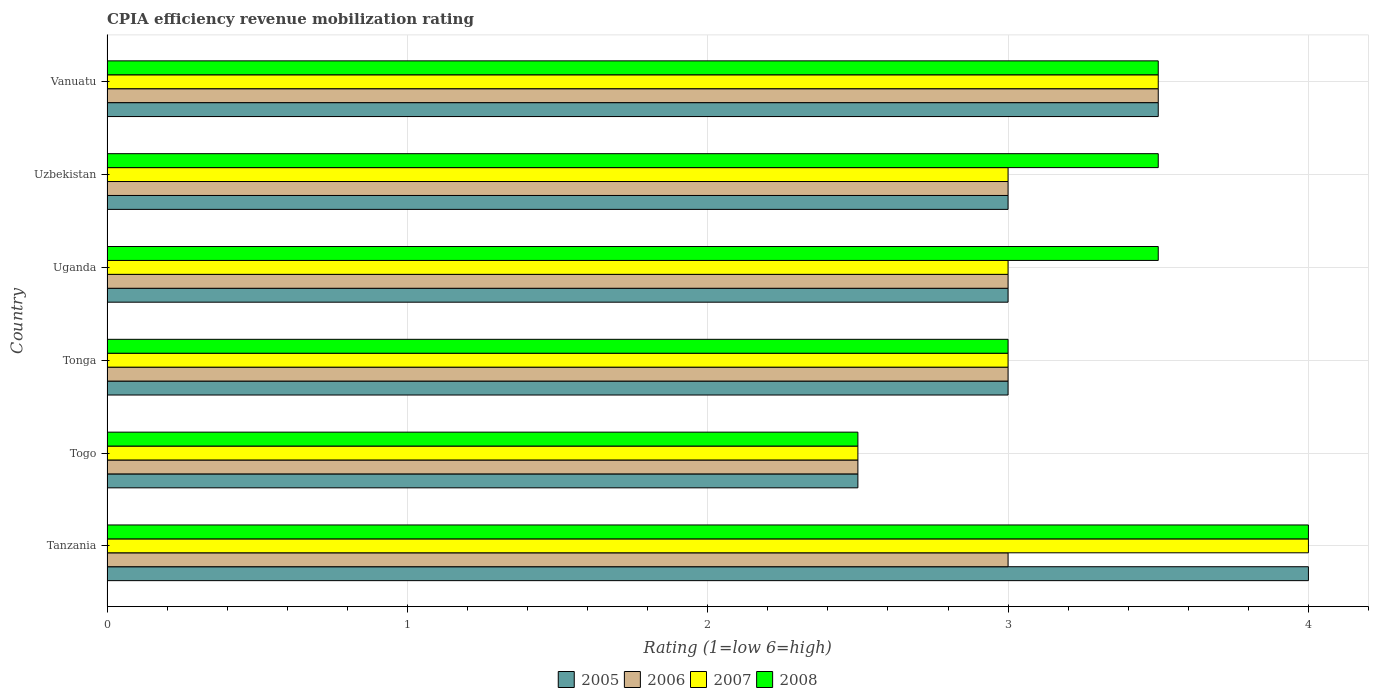Are the number of bars on each tick of the Y-axis equal?
Keep it short and to the point. Yes. How many bars are there on the 4th tick from the top?
Keep it short and to the point. 4. What is the label of the 1st group of bars from the top?
Provide a short and direct response. Vanuatu. In how many cases, is the number of bars for a given country not equal to the number of legend labels?
Your answer should be very brief. 0. Across all countries, what is the maximum CPIA rating in 2005?
Ensure brevity in your answer.  4. In which country was the CPIA rating in 2007 maximum?
Make the answer very short. Tanzania. In which country was the CPIA rating in 2008 minimum?
Give a very brief answer. Togo. What is the difference between the CPIA rating in 2007 in Togo and that in Tonga?
Offer a very short reply. -0.5. What is the difference between the CPIA rating in 2005 in Uzbekistan and the CPIA rating in 2008 in Togo?
Provide a succinct answer. 0.5. What is the average CPIA rating in 2007 per country?
Provide a succinct answer. 3.17. What is the ratio of the CPIA rating in 2008 in Togo to that in Uganda?
Provide a short and direct response. 0.71. Is the CPIA rating in 2007 in Tanzania less than that in Togo?
Keep it short and to the point. No. What is the difference between the highest and the second highest CPIA rating in 2006?
Your response must be concise. 0.5. In how many countries, is the CPIA rating in 2005 greater than the average CPIA rating in 2005 taken over all countries?
Your answer should be very brief. 2. What does the 2nd bar from the top in Uganda represents?
Your answer should be very brief. 2007. What does the 1st bar from the bottom in Tonga represents?
Give a very brief answer. 2005. What is the difference between two consecutive major ticks on the X-axis?
Your response must be concise. 1. Are the values on the major ticks of X-axis written in scientific E-notation?
Your response must be concise. No. Does the graph contain grids?
Offer a terse response. Yes. How many legend labels are there?
Give a very brief answer. 4. How are the legend labels stacked?
Your response must be concise. Horizontal. What is the title of the graph?
Your answer should be very brief. CPIA efficiency revenue mobilization rating. Does "1995" appear as one of the legend labels in the graph?
Your answer should be very brief. No. What is the label or title of the X-axis?
Ensure brevity in your answer.  Rating (1=low 6=high). What is the Rating (1=low 6=high) in 2008 in Tanzania?
Give a very brief answer. 4. What is the Rating (1=low 6=high) in 2008 in Togo?
Offer a very short reply. 2.5. What is the Rating (1=low 6=high) in 2006 in Tonga?
Your answer should be compact. 3. What is the Rating (1=low 6=high) in 2008 in Tonga?
Provide a succinct answer. 3. What is the Rating (1=low 6=high) in 2005 in Uganda?
Your response must be concise. 3. What is the Rating (1=low 6=high) in 2008 in Uganda?
Provide a succinct answer. 3.5. What is the Rating (1=low 6=high) of 2007 in Uzbekistan?
Give a very brief answer. 3. What is the Rating (1=low 6=high) of 2006 in Vanuatu?
Your answer should be very brief. 3.5. What is the Rating (1=low 6=high) of 2007 in Vanuatu?
Provide a short and direct response. 3.5. Across all countries, what is the maximum Rating (1=low 6=high) of 2005?
Offer a very short reply. 4. Across all countries, what is the maximum Rating (1=low 6=high) of 2006?
Offer a terse response. 3.5. Across all countries, what is the maximum Rating (1=low 6=high) of 2007?
Offer a very short reply. 4. Across all countries, what is the maximum Rating (1=low 6=high) of 2008?
Give a very brief answer. 4. Across all countries, what is the minimum Rating (1=low 6=high) of 2005?
Make the answer very short. 2.5. Across all countries, what is the minimum Rating (1=low 6=high) in 2007?
Offer a very short reply. 2.5. Across all countries, what is the minimum Rating (1=low 6=high) of 2008?
Provide a succinct answer. 2.5. What is the total Rating (1=low 6=high) of 2005 in the graph?
Your answer should be compact. 19. What is the total Rating (1=low 6=high) of 2006 in the graph?
Offer a terse response. 18. What is the difference between the Rating (1=low 6=high) of 2006 in Tanzania and that in Togo?
Provide a short and direct response. 0.5. What is the difference between the Rating (1=low 6=high) of 2007 in Tanzania and that in Tonga?
Your answer should be very brief. 1. What is the difference between the Rating (1=low 6=high) in 2008 in Tanzania and that in Tonga?
Give a very brief answer. 1. What is the difference between the Rating (1=low 6=high) of 2005 in Tanzania and that in Uganda?
Your answer should be very brief. 1. What is the difference between the Rating (1=low 6=high) in 2007 in Tanzania and that in Uganda?
Your answer should be compact. 1. What is the difference between the Rating (1=low 6=high) of 2005 in Tanzania and that in Uzbekistan?
Your response must be concise. 1. What is the difference between the Rating (1=low 6=high) of 2006 in Tanzania and that in Uzbekistan?
Your answer should be very brief. 0. What is the difference between the Rating (1=low 6=high) of 2005 in Tanzania and that in Vanuatu?
Offer a terse response. 0.5. What is the difference between the Rating (1=low 6=high) in 2006 in Togo and that in Tonga?
Your answer should be very brief. -0.5. What is the difference between the Rating (1=low 6=high) of 2006 in Togo and that in Uganda?
Ensure brevity in your answer.  -0.5. What is the difference between the Rating (1=low 6=high) of 2008 in Togo and that in Uganda?
Your answer should be compact. -1. What is the difference between the Rating (1=low 6=high) of 2006 in Togo and that in Uzbekistan?
Offer a very short reply. -0.5. What is the difference between the Rating (1=low 6=high) in 2008 in Togo and that in Uzbekistan?
Give a very brief answer. -1. What is the difference between the Rating (1=low 6=high) in 2006 in Togo and that in Vanuatu?
Your answer should be compact. -1. What is the difference between the Rating (1=low 6=high) of 2008 in Togo and that in Vanuatu?
Offer a terse response. -1. What is the difference between the Rating (1=low 6=high) of 2006 in Tonga and that in Uganda?
Provide a short and direct response. 0. What is the difference between the Rating (1=low 6=high) in 2007 in Tonga and that in Uzbekistan?
Provide a succinct answer. 0. What is the difference between the Rating (1=low 6=high) of 2008 in Tonga and that in Uzbekistan?
Give a very brief answer. -0.5. What is the difference between the Rating (1=low 6=high) of 2006 in Tonga and that in Vanuatu?
Give a very brief answer. -0.5. What is the difference between the Rating (1=low 6=high) of 2008 in Tonga and that in Vanuatu?
Offer a very short reply. -0.5. What is the difference between the Rating (1=low 6=high) of 2006 in Uganda and that in Uzbekistan?
Your response must be concise. 0. What is the difference between the Rating (1=low 6=high) in 2007 in Uganda and that in Uzbekistan?
Your answer should be compact. 0. What is the difference between the Rating (1=low 6=high) in 2007 in Uganda and that in Vanuatu?
Your answer should be very brief. -0.5. What is the difference between the Rating (1=low 6=high) of 2008 in Uganda and that in Vanuatu?
Offer a terse response. 0. What is the difference between the Rating (1=low 6=high) in 2005 in Uzbekistan and that in Vanuatu?
Your answer should be very brief. -0.5. What is the difference between the Rating (1=low 6=high) of 2008 in Uzbekistan and that in Vanuatu?
Provide a short and direct response. 0. What is the difference between the Rating (1=low 6=high) of 2005 in Tanzania and the Rating (1=low 6=high) of 2007 in Togo?
Offer a very short reply. 1.5. What is the difference between the Rating (1=low 6=high) in 2005 in Tanzania and the Rating (1=low 6=high) in 2008 in Togo?
Ensure brevity in your answer.  1.5. What is the difference between the Rating (1=low 6=high) of 2007 in Tanzania and the Rating (1=low 6=high) of 2008 in Togo?
Keep it short and to the point. 1.5. What is the difference between the Rating (1=low 6=high) in 2005 in Tanzania and the Rating (1=low 6=high) in 2007 in Tonga?
Provide a short and direct response. 1. What is the difference between the Rating (1=low 6=high) in 2006 in Tanzania and the Rating (1=low 6=high) in 2007 in Tonga?
Your response must be concise. 0. What is the difference between the Rating (1=low 6=high) in 2006 in Tanzania and the Rating (1=low 6=high) in 2008 in Uganda?
Ensure brevity in your answer.  -0.5. What is the difference between the Rating (1=low 6=high) in 2007 in Tanzania and the Rating (1=low 6=high) in 2008 in Uganda?
Provide a short and direct response. 0.5. What is the difference between the Rating (1=low 6=high) in 2005 in Tanzania and the Rating (1=low 6=high) in 2006 in Uzbekistan?
Your answer should be compact. 1. What is the difference between the Rating (1=low 6=high) in 2006 in Tanzania and the Rating (1=low 6=high) in 2007 in Uzbekistan?
Make the answer very short. 0. What is the difference between the Rating (1=low 6=high) of 2007 in Tanzania and the Rating (1=low 6=high) of 2008 in Uzbekistan?
Your response must be concise. 0.5. What is the difference between the Rating (1=low 6=high) in 2005 in Tanzania and the Rating (1=low 6=high) in 2006 in Vanuatu?
Offer a very short reply. 0.5. What is the difference between the Rating (1=low 6=high) of 2005 in Tanzania and the Rating (1=low 6=high) of 2007 in Vanuatu?
Your answer should be very brief. 0.5. What is the difference between the Rating (1=low 6=high) in 2005 in Tanzania and the Rating (1=low 6=high) in 2008 in Vanuatu?
Provide a short and direct response. 0.5. What is the difference between the Rating (1=low 6=high) of 2006 in Tanzania and the Rating (1=low 6=high) of 2007 in Vanuatu?
Ensure brevity in your answer.  -0.5. What is the difference between the Rating (1=low 6=high) of 2006 in Tanzania and the Rating (1=low 6=high) of 2008 in Vanuatu?
Offer a terse response. -0.5. What is the difference between the Rating (1=low 6=high) of 2007 in Tanzania and the Rating (1=low 6=high) of 2008 in Vanuatu?
Ensure brevity in your answer.  0.5. What is the difference between the Rating (1=low 6=high) in 2005 in Togo and the Rating (1=low 6=high) in 2006 in Tonga?
Make the answer very short. -0.5. What is the difference between the Rating (1=low 6=high) in 2007 in Togo and the Rating (1=low 6=high) in 2008 in Tonga?
Your answer should be very brief. -0.5. What is the difference between the Rating (1=low 6=high) of 2005 in Togo and the Rating (1=low 6=high) of 2007 in Uganda?
Offer a very short reply. -0.5. What is the difference between the Rating (1=low 6=high) in 2005 in Togo and the Rating (1=low 6=high) in 2006 in Uzbekistan?
Keep it short and to the point. -0.5. What is the difference between the Rating (1=low 6=high) in 2005 in Togo and the Rating (1=low 6=high) in 2007 in Uzbekistan?
Keep it short and to the point. -0.5. What is the difference between the Rating (1=low 6=high) in 2006 in Togo and the Rating (1=low 6=high) in 2007 in Uzbekistan?
Your answer should be compact. -0.5. What is the difference between the Rating (1=low 6=high) in 2007 in Togo and the Rating (1=low 6=high) in 2008 in Uzbekistan?
Provide a succinct answer. -1. What is the difference between the Rating (1=low 6=high) in 2005 in Togo and the Rating (1=low 6=high) in 2007 in Vanuatu?
Offer a very short reply. -1. What is the difference between the Rating (1=low 6=high) of 2005 in Tonga and the Rating (1=low 6=high) of 2006 in Uganda?
Provide a short and direct response. 0. What is the difference between the Rating (1=low 6=high) in 2005 in Tonga and the Rating (1=low 6=high) in 2007 in Uganda?
Keep it short and to the point. 0. What is the difference between the Rating (1=low 6=high) of 2006 in Tonga and the Rating (1=low 6=high) of 2008 in Uganda?
Offer a very short reply. -0.5. What is the difference between the Rating (1=low 6=high) in 2007 in Tonga and the Rating (1=low 6=high) in 2008 in Uganda?
Provide a short and direct response. -0.5. What is the difference between the Rating (1=low 6=high) of 2005 in Tonga and the Rating (1=low 6=high) of 2008 in Uzbekistan?
Offer a very short reply. -0.5. What is the difference between the Rating (1=low 6=high) in 2006 in Tonga and the Rating (1=low 6=high) in 2007 in Uzbekistan?
Your answer should be compact. 0. What is the difference between the Rating (1=low 6=high) in 2006 in Tonga and the Rating (1=low 6=high) in 2008 in Uzbekistan?
Offer a very short reply. -0.5. What is the difference between the Rating (1=low 6=high) of 2005 in Tonga and the Rating (1=low 6=high) of 2006 in Vanuatu?
Offer a terse response. -0.5. What is the difference between the Rating (1=low 6=high) of 2005 in Tonga and the Rating (1=low 6=high) of 2007 in Vanuatu?
Provide a succinct answer. -0.5. What is the difference between the Rating (1=low 6=high) in 2005 in Tonga and the Rating (1=low 6=high) in 2008 in Vanuatu?
Keep it short and to the point. -0.5. What is the difference between the Rating (1=low 6=high) in 2006 in Tonga and the Rating (1=low 6=high) in 2007 in Vanuatu?
Offer a terse response. -0.5. What is the difference between the Rating (1=low 6=high) in 2006 in Tonga and the Rating (1=low 6=high) in 2008 in Vanuatu?
Your answer should be very brief. -0.5. What is the difference between the Rating (1=low 6=high) in 2007 in Tonga and the Rating (1=low 6=high) in 2008 in Vanuatu?
Make the answer very short. -0.5. What is the difference between the Rating (1=low 6=high) in 2005 in Uganda and the Rating (1=low 6=high) in 2007 in Uzbekistan?
Provide a succinct answer. 0. What is the difference between the Rating (1=low 6=high) in 2006 in Uganda and the Rating (1=low 6=high) in 2007 in Uzbekistan?
Offer a terse response. 0. What is the difference between the Rating (1=low 6=high) in 2006 in Uganda and the Rating (1=low 6=high) in 2008 in Uzbekistan?
Provide a succinct answer. -0.5. What is the difference between the Rating (1=low 6=high) of 2005 in Uganda and the Rating (1=low 6=high) of 2008 in Vanuatu?
Make the answer very short. -0.5. What is the difference between the Rating (1=low 6=high) of 2006 in Uganda and the Rating (1=low 6=high) of 2007 in Vanuatu?
Provide a short and direct response. -0.5. What is the difference between the Rating (1=low 6=high) in 2005 in Uzbekistan and the Rating (1=low 6=high) in 2008 in Vanuatu?
Make the answer very short. -0.5. What is the difference between the Rating (1=low 6=high) of 2006 in Uzbekistan and the Rating (1=low 6=high) of 2007 in Vanuatu?
Make the answer very short. -0.5. What is the average Rating (1=low 6=high) of 2005 per country?
Ensure brevity in your answer.  3.17. What is the average Rating (1=low 6=high) of 2007 per country?
Keep it short and to the point. 3.17. What is the difference between the Rating (1=low 6=high) of 2005 and Rating (1=low 6=high) of 2006 in Tanzania?
Your answer should be compact. 1. What is the difference between the Rating (1=low 6=high) of 2005 and Rating (1=low 6=high) of 2006 in Togo?
Keep it short and to the point. 0. What is the difference between the Rating (1=low 6=high) in 2006 and Rating (1=low 6=high) in 2008 in Togo?
Offer a very short reply. 0. What is the difference between the Rating (1=low 6=high) in 2007 and Rating (1=low 6=high) in 2008 in Togo?
Give a very brief answer. 0. What is the difference between the Rating (1=low 6=high) in 2005 and Rating (1=low 6=high) in 2006 in Tonga?
Make the answer very short. 0. What is the difference between the Rating (1=low 6=high) in 2006 and Rating (1=low 6=high) in 2007 in Tonga?
Offer a terse response. 0. What is the difference between the Rating (1=low 6=high) in 2006 and Rating (1=low 6=high) in 2008 in Tonga?
Give a very brief answer. 0. What is the difference between the Rating (1=low 6=high) in 2005 and Rating (1=low 6=high) in 2007 in Uganda?
Your response must be concise. 0. What is the difference between the Rating (1=low 6=high) of 2005 and Rating (1=low 6=high) of 2008 in Uganda?
Keep it short and to the point. -0.5. What is the difference between the Rating (1=low 6=high) of 2005 and Rating (1=low 6=high) of 2006 in Uzbekistan?
Ensure brevity in your answer.  0. What is the difference between the Rating (1=low 6=high) in 2005 and Rating (1=low 6=high) in 2008 in Uzbekistan?
Give a very brief answer. -0.5. What is the difference between the Rating (1=low 6=high) in 2006 and Rating (1=low 6=high) in 2008 in Uzbekistan?
Provide a short and direct response. -0.5. What is the difference between the Rating (1=low 6=high) in 2007 and Rating (1=low 6=high) in 2008 in Uzbekistan?
Provide a short and direct response. -0.5. What is the difference between the Rating (1=low 6=high) in 2005 and Rating (1=low 6=high) in 2006 in Vanuatu?
Your answer should be compact. 0. What is the difference between the Rating (1=low 6=high) of 2006 and Rating (1=low 6=high) of 2007 in Vanuatu?
Provide a succinct answer. 0. What is the difference between the Rating (1=low 6=high) of 2006 and Rating (1=low 6=high) of 2008 in Vanuatu?
Give a very brief answer. 0. What is the difference between the Rating (1=low 6=high) in 2007 and Rating (1=low 6=high) in 2008 in Vanuatu?
Your answer should be very brief. 0. What is the ratio of the Rating (1=low 6=high) in 2005 in Tanzania to that in Uzbekistan?
Make the answer very short. 1.33. What is the ratio of the Rating (1=low 6=high) in 2007 in Tanzania to that in Uzbekistan?
Offer a terse response. 1.33. What is the ratio of the Rating (1=low 6=high) of 2008 in Tanzania to that in Uzbekistan?
Your answer should be compact. 1.14. What is the ratio of the Rating (1=low 6=high) in 2007 in Tanzania to that in Vanuatu?
Make the answer very short. 1.14. What is the ratio of the Rating (1=low 6=high) in 2008 in Tanzania to that in Vanuatu?
Provide a succinct answer. 1.14. What is the ratio of the Rating (1=low 6=high) in 2007 in Togo to that in Tonga?
Provide a short and direct response. 0.83. What is the ratio of the Rating (1=low 6=high) in 2008 in Togo to that in Tonga?
Keep it short and to the point. 0.83. What is the ratio of the Rating (1=low 6=high) in 2005 in Togo to that in Uganda?
Your response must be concise. 0.83. What is the ratio of the Rating (1=low 6=high) of 2005 in Togo to that in Vanuatu?
Your answer should be very brief. 0.71. What is the ratio of the Rating (1=low 6=high) of 2007 in Togo to that in Vanuatu?
Provide a short and direct response. 0.71. What is the ratio of the Rating (1=low 6=high) of 2008 in Togo to that in Vanuatu?
Your answer should be compact. 0.71. What is the ratio of the Rating (1=low 6=high) in 2005 in Tonga to that in Uganda?
Offer a very short reply. 1. What is the ratio of the Rating (1=low 6=high) of 2006 in Tonga to that in Uzbekistan?
Provide a succinct answer. 1. What is the ratio of the Rating (1=low 6=high) in 2005 in Uganda to that in Vanuatu?
Your answer should be very brief. 0.86. What is the ratio of the Rating (1=low 6=high) in 2006 in Uganda to that in Vanuatu?
Offer a very short reply. 0.86. What is the ratio of the Rating (1=low 6=high) in 2007 in Uganda to that in Vanuatu?
Provide a short and direct response. 0.86. What is the ratio of the Rating (1=low 6=high) of 2005 in Uzbekistan to that in Vanuatu?
Make the answer very short. 0.86. What is the ratio of the Rating (1=low 6=high) of 2006 in Uzbekistan to that in Vanuatu?
Give a very brief answer. 0.86. What is the ratio of the Rating (1=low 6=high) in 2008 in Uzbekistan to that in Vanuatu?
Ensure brevity in your answer.  1. What is the difference between the highest and the second highest Rating (1=low 6=high) of 2007?
Offer a very short reply. 0.5. What is the difference between the highest and the second highest Rating (1=low 6=high) of 2008?
Your response must be concise. 0.5. What is the difference between the highest and the lowest Rating (1=low 6=high) of 2005?
Your answer should be compact. 1.5. What is the difference between the highest and the lowest Rating (1=low 6=high) of 2006?
Your answer should be very brief. 1. What is the difference between the highest and the lowest Rating (1=low 6=high) in 2008?
Give a very brief answer. 1.5. 